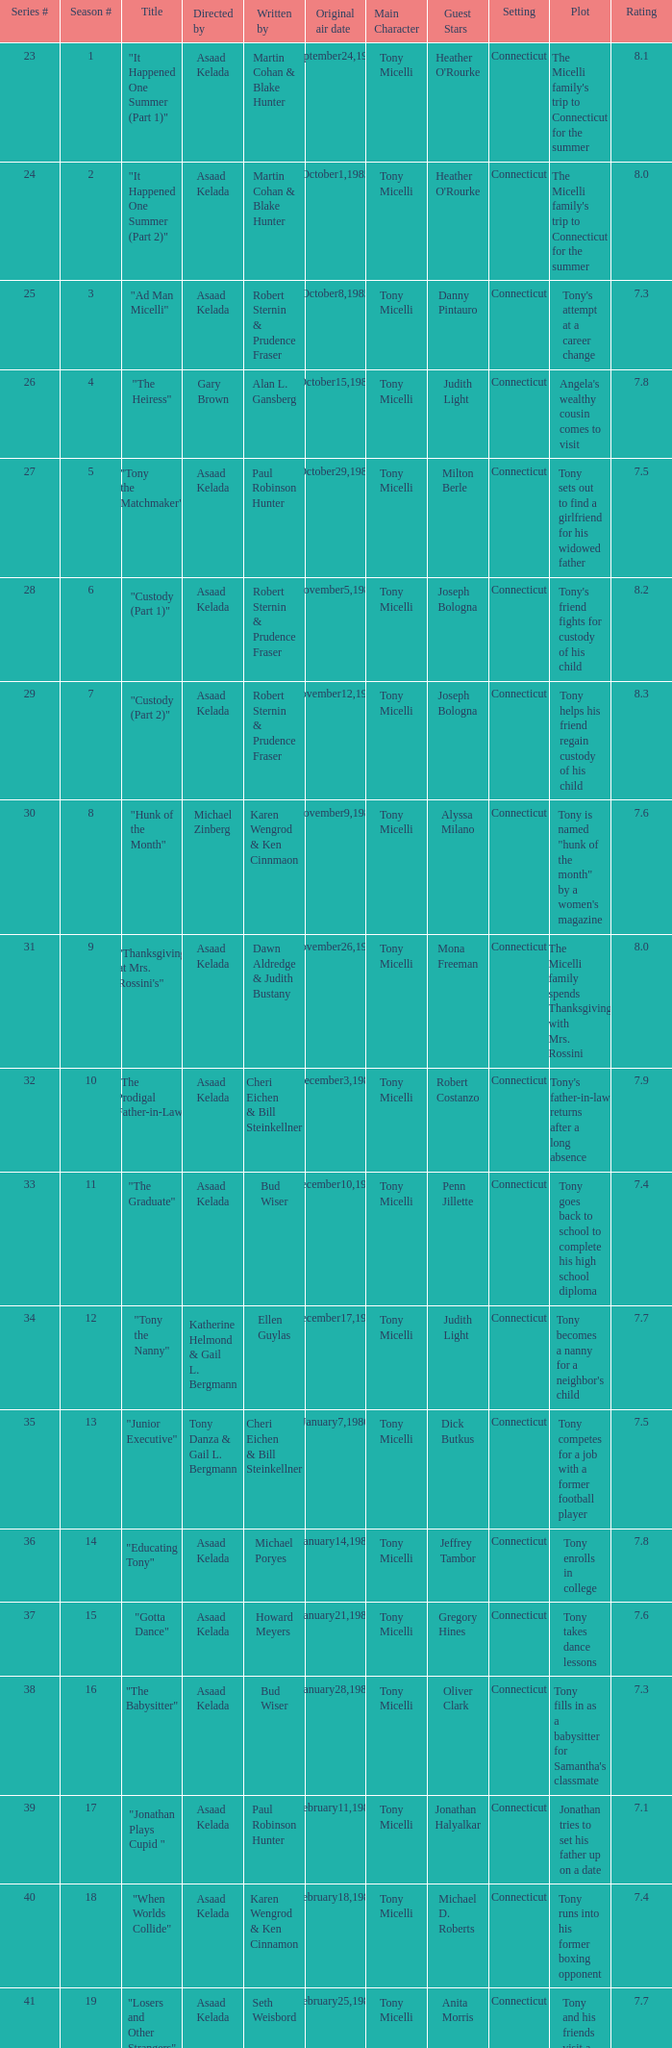What is the date of the episode written by Michael Poryes? January14,1986. 